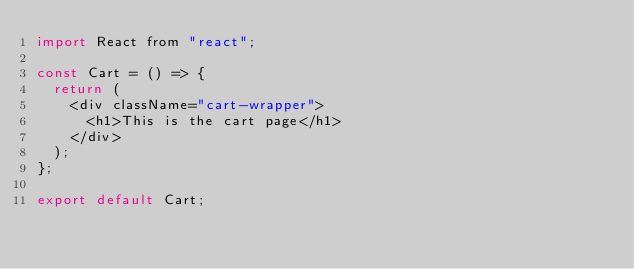<code> <loc_0><loc_0><loc_500><loc_500><_JavaScript_>import React from "react";

const Cart = () => {
  return (
    <div className="cart-wrapper">
      <h1>This is the cart page</h1>
    </div>
  );
};

export default Cart;
</code> 